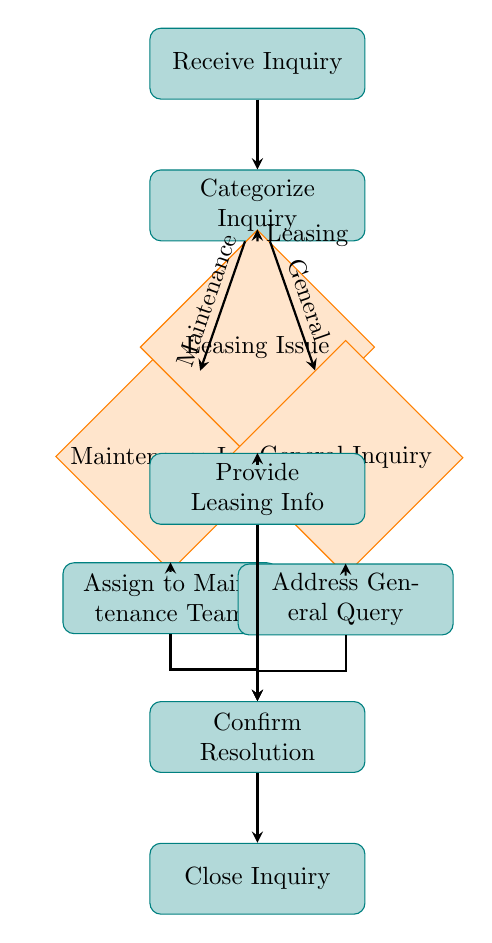What is the starting point of the flow chart? The flow chart starts with the node labeled "Receive Inquiry," which indicates the initial action in the tenant inquiry resolution process.
Answer: Receive Inquiry How many nodes are there in total? By counting the nodes listed in the diagram, there are 10 distinct nodes, each representing a different step in the resolution process.
Answer: 10 What is the first node after "Categorize Inquiry"? After "Categorize Inquiry," the first decision node that represents the next possible steps is "Maintenance Issue." This indicates the branching point for maintenance-related inquiries.
Answer: Maintenance Issue Which process follows a maintenance issue? After identifying a maintenance issue, the next step is to "Assign to Maintenance Team," which details the action to resolve the inquiry.
Answer: Assign to Maintenance Team If an inquiry is leasing-related, what is the next action? The step that follows a leasing-related inquiry is to "Provide Leasing Info," which indicates how to proceed when the inquiry is about leasing matters.
Answer: Provide Leasing Info What happens after confirming a resolution? Once a resolution is confirmed, the next and final action in the process is "Close Inquiry," marking the end of the inquiry resolution cycle.
Answer: Close Inquiry How are general inquiries addressed? General inquiries are addressed by the node "Address General Query," which specifies how these types of inquiries are managed in the process.
Answer: Address General Query How many edges originate from the "Categorize Inquiry" node? There are three edges originating from the "Categorize Inquiry" node, directing to the three different inquiry types: Maintenance, Leasing, and General.
Answer: 3 What indicates the transition from a resolved inquiry to closing it? The transition from a resolved inquiry to closing it is indicated by the node "Confirm Resolution," which connects to "Close Inquiry," showing the final confirmation step before closure.
Answer: Confirm Resolution Which type of issue leads directly to a team assignment? The type of issue that leads directly to a team assignment is a "Maintenance Issue," where inquiries are forwarded to the maintenance team for resolution.
Answer: Maintenance Issue 